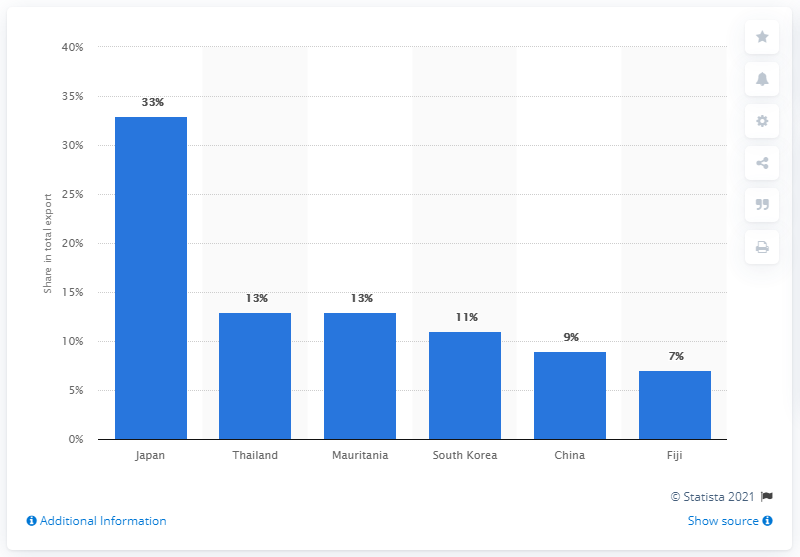Outline some significant characteristics in this image. In 2019, Japan was the most important export partner of Vanuatu. 